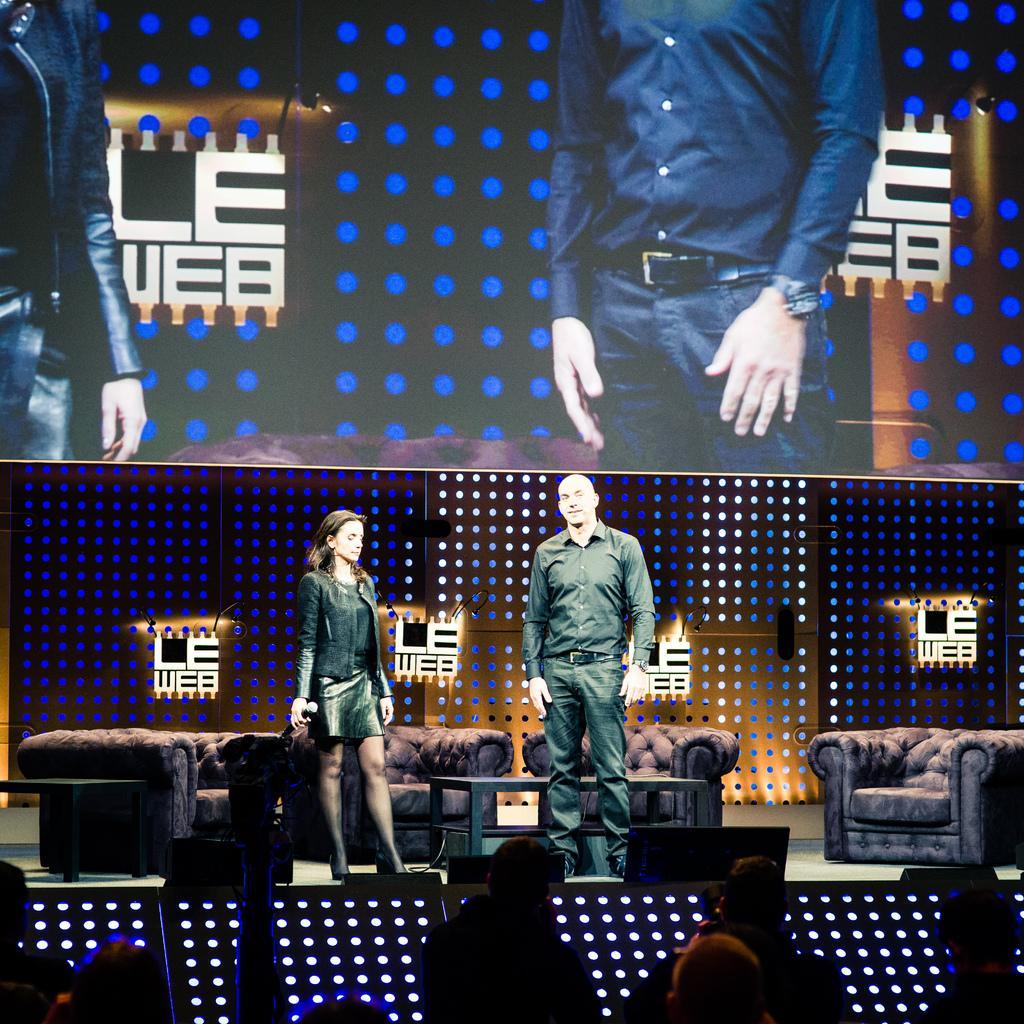Could you give a brief overview of what you see in this image? Here we can see a screen. On this screen we can see two people. On this stage there are people, chairs and table. These are audience. 